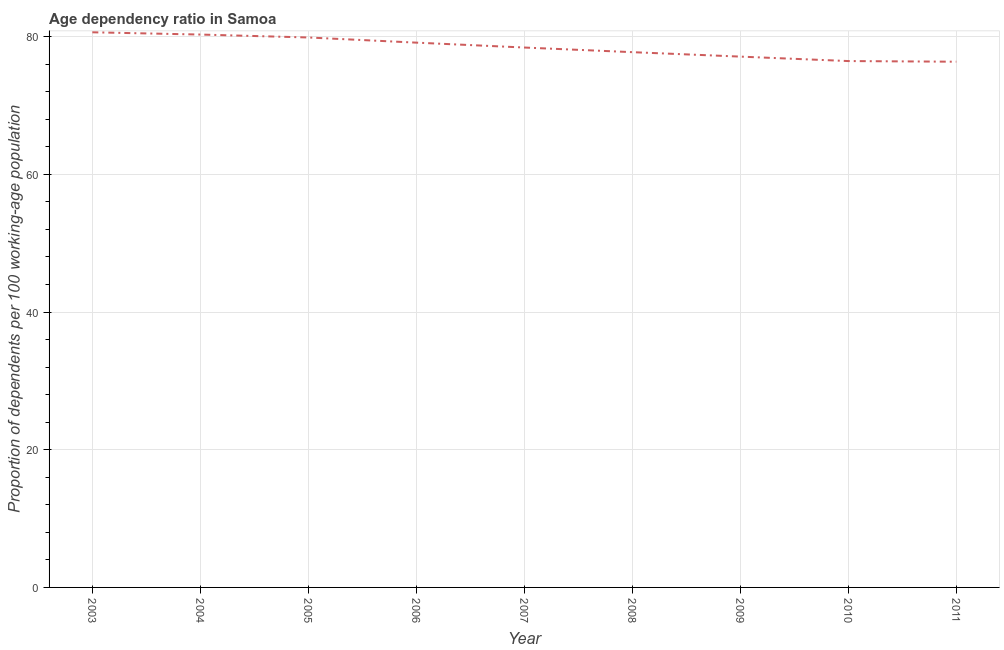What is the age dependency ratio in 2003?
Offer a very short reply. 80.63. Across all years, what is the maximum age dependency ratio?
Keep it short and to the point. 80.63. Across all years, what is the minimum age dependency ratio?
Provide a succinct answer. 76.35. In which year was the age dependency ratio minimum?
Give a very brief answer. 2011. What is the sum of the age dependency ratio?
Ensure brevity in your answer.  705.98. What is the difference between the age dependency ratio in 2005 and 2006?
Offer a terse response. 0.75. What is the average age dependency ratio per year?
Ensure brevity in your answer.  78.44. What is the median age dependency ratio?
Ensure brevity in your answer.  78.41. Do a majority of the years between 2011 and 2005 (inclusive) have age dependency ratio greater than 28 ?
Your answer should be compact. Yes. What is the ratio of the age dependency ratio in 2008 to that in 2011?
Offer a terse response. 1.02. What is the difference between the highest and the second highest age dependency ratio?
Ensure brevity in your answer.  0.33. Is the sum of the age dependency ratio in 2006 and 2007 greater than the maximum age dependency ratio across all years?
Provide a short and direct response. Yes. What is the difference between the highest and the lowest age dependency ratio?
Offer a terse response. 4.27. How many lines are there?
Make the answer very short. 1. What is the title of the graph?
Your answer should be compact. Age dependency ratio in Samoa. What is the label or title of the X-axis?
Provide a succinct answer. Year. What is the label or title of the Y-axis?
Your response must be concise. Proportion of dependents per 100 working-age population. What is the Proportion of dependents per 100 working-age population in 2003?
Make the answer very short. 80.63. What is the Proportion of dependents per 100 working-age population of 2004?
Ensure brevity in your answer.  80.3. What is the Proportion of dependents per 100 working-age population in 2005?
Your answer should be very brief. 79.87. What is the Proportion of dependents per 100 working-age population in 2006?
Your answer should be very brief. 79.12. What is the Proportion of dependents per 100 working-age population in 2007?
Ensure brevity in your answer.  78.41. What is the Proportion of dependents per 100 working-age population in 2008?
Keep it short and to the point. 77.74. What is the Proportion of dependents per 100 working-age population in 2009?
Offer a very short reply. 77.1. What is the Proportion of dependents per 100 working-age population of 2010?
Provide a short and direct response. 76.45. What is the Proportion of dependents per 100 working-age population in 2011?
Make the answer very short. 76.35. What is the difference between the Proportion of dependents per 100 working-age population in 2003 and 2004?
Provide a short and direct response. 0.33. What is the difference between the Proportion of dependents per 100 working-age population in 2003 and 2005?
Give a very brief answer. 0.75. What is the difference between the Proportion of dependents per 100 working-age population in 2003 and 2006?
Make the answer very short. 1.5. What is the difference between the Proportion of dependents per 100 working-age population in 2003 and 2007?
Your response must be concise. 2.21. What is the difference between the Proportion of dependents per 100 working-age population in 2003 and 2008?
Your response must be concise. 2.89. What is the difference between the Proportion of dependents per 100 working-age population in 2003 and 2009?
Offer a very short reply. 3.53. What is the difference between the Proportion of dependents per 100 working-age population in 2003 and 2010?
Your answer should be compact. 4.18. What is the difference between the Proportion of dependents per 100 working-age population in 2003 and 2011?
Make the answer very short. 4.27. What is the difference between the Proportion of dependents per 100 working-age population in 2004 and 2005?
Ensure brevity in your answer.  0.43. What is the difference between the Proportion of dependents per 100 working-age population in 2004 and 2006?
Offer a very short reply. 1.17. What is the difference between the Proportion of dependents per 100 working-age population in 2004 and 2007?
Keep it short and to the point. 1.88. What is the difference between the Proportion of dependents per 100 working-age population in 2004 and 2008?
Offer a very short reply. 2.56. What is the difference between the Proportion of dependents per 100 working-age population in 2004 and 2009?
Ensure brevity in your answer.  3.2. What is the difference between the Proportion of dependents per 100 working-age population in 2004 and 2010?
Offer a very short reply. 3.85. What is the difference between the Proportion of dependents per 100 working-age population in 2004 and 2011?
Ensure brevity in your answer.  3.95. What is the difference between the Proportion of dependents per 100 working-age population in 2005 and 2006?
Provide a short and direct response. 0.75. What is the difference between the Proportion of dependents per 100 working-age population in 2005 and 2007?
Your answer should be compact. 1.46. What is the difference between the Proportion of dependents per 100 working-age population in 2005 and 2008?
Provide a short and direct response. 2.13. What is the difference between the Proportion of dependents per 100 working-age population in 2005 and 2009?
Keep it short and to the point. 2.78. What is the difference between the Proportion of dependents per 100 working-age population in 2005 and 2010?
Provide a short and direct response. 3.42. What is the difference between the Proportion of dependents per 100 working-age population in 2005 and 2011?
Provide a succinct answer. 3.52. What is the difference between the Proportion of dependents per 100 working-age population in 2006 and 2007?
Ensure brevity in your answer.  0.71. What is the difference between the Proportion of dependents per 100 working-age population in 2006 and 2008?
Keep it short and to the point. 1.38. What is the difference between the Proportion of dependents per 100 working-age population in 2006 and 2009?
Ensure brevity in your answer.  2.03. What is the difference between the Proportion of dependents per 100 working-age population in 2006 and 2010?
Provide a short and direct response. 2.68. What is the difference between the Proportion of dependents per 100 working-age population in 2006 and 2011?
Your response must be concise. 2.77. What is the difference between the Proportion of dependents per 100 working-age population in 2007 and 2008?
Provide a short and direct response. 0.67. What is the difference between the Proportion of dependents per 100 working-age population in 2007 and 2009?
Provide a succinct answer. 1.32. What is the difference between the Proportion of dependents per 100 working-age population in 2007 and 2010?
Provide a short and direct response. 1.97. What is the difference between the Proportion of dependents per 100 working-age population in 2007 and 2011?
Give a very brief answer. 2.06. What is the difference between the Proportion of dependents per 100 working-age population in 2008 and 2009?
Give a very brief answer. 0.65. What is the difference between the Proportion of dependents per 100 working-age population in 2008 and 2010?
Ensure brevity in your answer.  1.29. What is the difference between the Proportion of dependents per 100 working-age population in 2008 and 2011?
Your answer should be very brief. 1.39. What is the difference between the Proportion of dependents per 100 working-age population in 2009 and 2010?
Offer a terse response. 0.65. What is the difference between the Proportion of dependents per 100 working-age population in 2009 and 2011?
Your answer should be compact. 0.74. What is the difference between the Proportion of dependents per 100 working-age population in 2010 and 2011?
Provide a succinct answer. 0.1. What is the ratio of the Proportion of dependents per 100 working-age population in 2003 to that in 2004?
Offer a terse response. 1. What is the ratio of the Proportion of dependents per 100 working-age population in 2003 to that in 2006?
Ensure brevity in your answer.  1.02. What is the ratio of the Proportion of dependents per 100 working-age population in 2003 to that in 2007?
Give a very brief answer. 1.03. What is the ratio of the Proportion of dependents per 100 working-age population in 2003 to that in 2008?
Provide a short and direct response. 1.04. What is the ratio of the Proportion of dependents per 100 working-age population in 2003 to that in 2009?
Your response must be concise. 1.05. What is the ratio of the Proportion of dependents per 100 working-age population in 2003 to that in 2010?
Your answer should be compact. 1.05. What is the ratio of the Proportion of dependents per 100 working-age population in 2003 to that in 2011?
Your answer should be very brief. 1.06. What is the ratio of the Proportion of dependents per 100 working-age population in 2004 to that in 2005?
Your answer should be very brief. 1. What is the ratio of the Proportion of dependents per 100 working-age population in 2004 to that in 2008?
Offer a terse response. 1.03. What is the ratio of the Proportion of dependents per 100 working-age population in 2004 to that in 2009?
Your response must be concise. 1.04. What is the ratio of the Proportion of dependents per 100 working-age population in 2004 to that in 2010?
Provide a short and direct response. 1.05. What is the ratio of the Proportion of dependents per 100 working-age population in 2004 to that in 2011?
Your answer should be compact. 1.05. What is the ratio of the Proportion of dependents per 100 working-age population in 2005 to that in 2009?
Provide a short and direct response. 1.04. What is the ratio of the Proportion of dependents per 100 working-age population in 2005 to that in 2010?
Offer a very short reply. 1.04. What is the ratio of the Proportion of dependents per 100 working-age population in 2005 to that in 2011?
Your answer should be very brief. 1.05. What is the ratio of the Proportion of dependents per 100 working-age population in 2006 to that in 2010?
Provide a short and direct response. 1.03. What is the ratio of the Proportion of dependents per 100 working-age population in 2006 to that in 2011?
Make the answer very short. 1.04. What is the ratio of the Proportion of dependents per 100 working-age population in 2007 to that in 2008?
Keep it short and to the point. 1.01. What is the ratio of the Proportion of dependents per 100 working-age population in 2007 to that in 2009?
Keep it short and to the point. 1.02. What is the ratio of the Proportion of dependents per 100 working-age population in 2007 to that in 2011?
Provide a short and direct response. 1.03. What is the ratio of the Proportion of dependents per 100 working-age population in 2008 to that in 2009?
Provide a succinct answer. 1.01. What is the ratio of the Proportion of dependents per 100 working-age population in 2008 to that in 2010?
Make the answer very short. 1.02. What is the ratio of the Proportion of dependents per 100 working-age population in 2009 to that in 2010?
Provide a short and direct response. 1.01. What is the ratio of the Proportion of dependents per 100 working-age population in 2009 to that in 2011?
Make the answer very short. 1.01. What is the ratio of the Proportion of dependents per 100 working-age population in 2010 to that in 2011?
Offer a terse response. 1. 